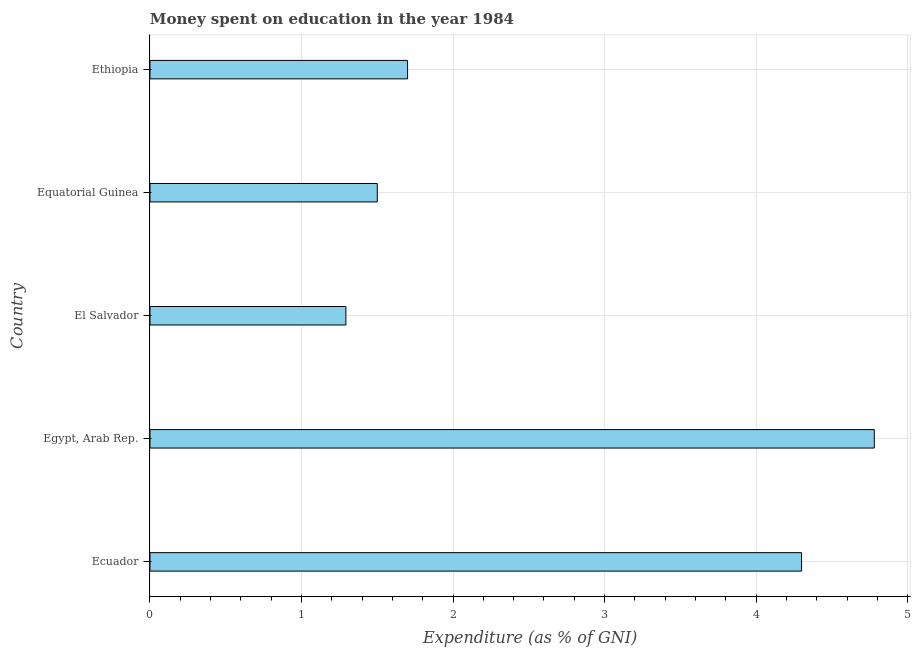Does the graph contain grids?
Your answer should be compact. Yes. What is the title of the graph?
Give a very brief answer. Money spent on education in the year 1984. What is the label or title of the X-axis?
Keep it short and to the point. Expenditure (as % of GNI). What is the expenditure on education in Egypt, Arab Rep.?
Ensure brevity in your answer.  4.78. Across all countries, what is the maximum expenditure on education?
Provide a short and direct response. 4.78. Across all countries, what is the minimum expenditure on education?
Ensure brevity in your answer.  1.29. In which country was the expenditure on education maximum?
Your answer should be very brief. Egypt, Arab Rep. In which country was the expenditure on education minimum?
Make the answer very short. El Salvador. What is the sum of the expenditure on education?
Your answer should be very brief. 13.57. What is the difference between the expenditure on education in Egypt, Arab Rep. and Equatorial Guinea?
Your answer should be compact. 3.28. What is the average expenditure on education per country?
Your answer should be compact. 2.71. What is the ratio of the expenditure on education in El Salvador to that in Equatorial Guinea?
Keep it short and to the point. 0.86. Is the expenditure on education in El Salvador less than that in Ethiopia?
Provide a succinct answer. Yes. What is the difference between the highest and the second highest expenditure on education?
Your answer should be very brief. 0.48. Is the sum of the expenditure on education in Equatorial Guinea and Ethiopia greater than the maximum expenditure on education across all countries?
Your answer should be compact. No. What is the difference between the highest and the lowest expenditure on education?
Offer a very short reply. 3.49. Are all the bars in the graph horizontal?
Provide a short and direct response. Yes. What is the Expenditure (as % of GNI) in Egypt, Arab Rep.?
Offer a very short reply. 4.78. What is the Expenditure (as % of GNI) of El Salvador?
Your answer should be compact. 1.29. What is the Expenditure (as % of GNI) in Ethiopia?
Your answer should be compact. 1.7. What is the difference between the Expenditure (as % of GNI) in Ecuador and Egypt, Arab Rep.?
Your answer should be compact. -0.48. What is the difference between the Expenditure (as % of GNI) in Ecuador and El Salvador?
Make the answer very short. 3.01. What is the difference between the Expenditure (as % of GNI) in Ecuador and Ethiopia?
Offer a terse response. 2.6. What is the difference between the Expenditure (as % of GNI) in Egypt, Arab Rep. and El Salvador?
Offer a very short reply. 3.49. What is the difference between the Expenditure (as % of GNI) in Egypt, Arab Rep. and Equatorial Guinea?
Your answer should be compact. 3.28. What is the difference between the Expenditure (as % of GNI) in Egypt, Arab Rep. and Ethiopia?
Provide a succinct answer. 3.08. What is the difference between the Expenditure (as % of GNI) in El Salvador and Equatorial Guinea?
Your answer should be very brief. -0.21. What is the difference between the Expenditure (as % of GNI) in El Salvador and Ethiopia?
Ensure brevity in your answer.  -0.41. What is the ratio of the Expenditure (as % of GNI) in Ecuador to that in El Salvador?
Keep it short and to the point. 3.33. What is the ratio of the Expenditure (as % of GNI) in Ecuador to that in Equatorial Guinea?
Make the answer very short. 2.87. What is the ratio of the Expenditure (as % of GNI) in Ecuador to that in Ethiopia?
Keep it short and to the point. 2.53. What is the ratio of the Expenditure (as % of GNI) in Egypt, Arab Rep. to that in El Salvador?
Provide a succinct answer. 3.7. What is the ratio of the Expenditure (as % of GNI) in Egypt, Arab Rep. to that in Equatorial Guinea?
Ensure brevity in your answer.  3.19. What is the ratio of the Expenditure (as % of GNI) in Egypt, Arab Rep. to that in Ethiopia?
Offer a very short reply. 2.81. What is the ratio of the Expenditure (as % of GNI) in El Salvador to that in Equatorial Guinea?
Provide a succinct answer. 0.86. What is the ratio of the Expenditure (as % of GNI) in El Salvador to that in Ethiopia?
Make the answer very short. 0.76. What is the ratio of the Expenditure (as % of GNI) in Equatorial Guinea to that in Ethiopia?
Your answer should be compact. 0.88. 